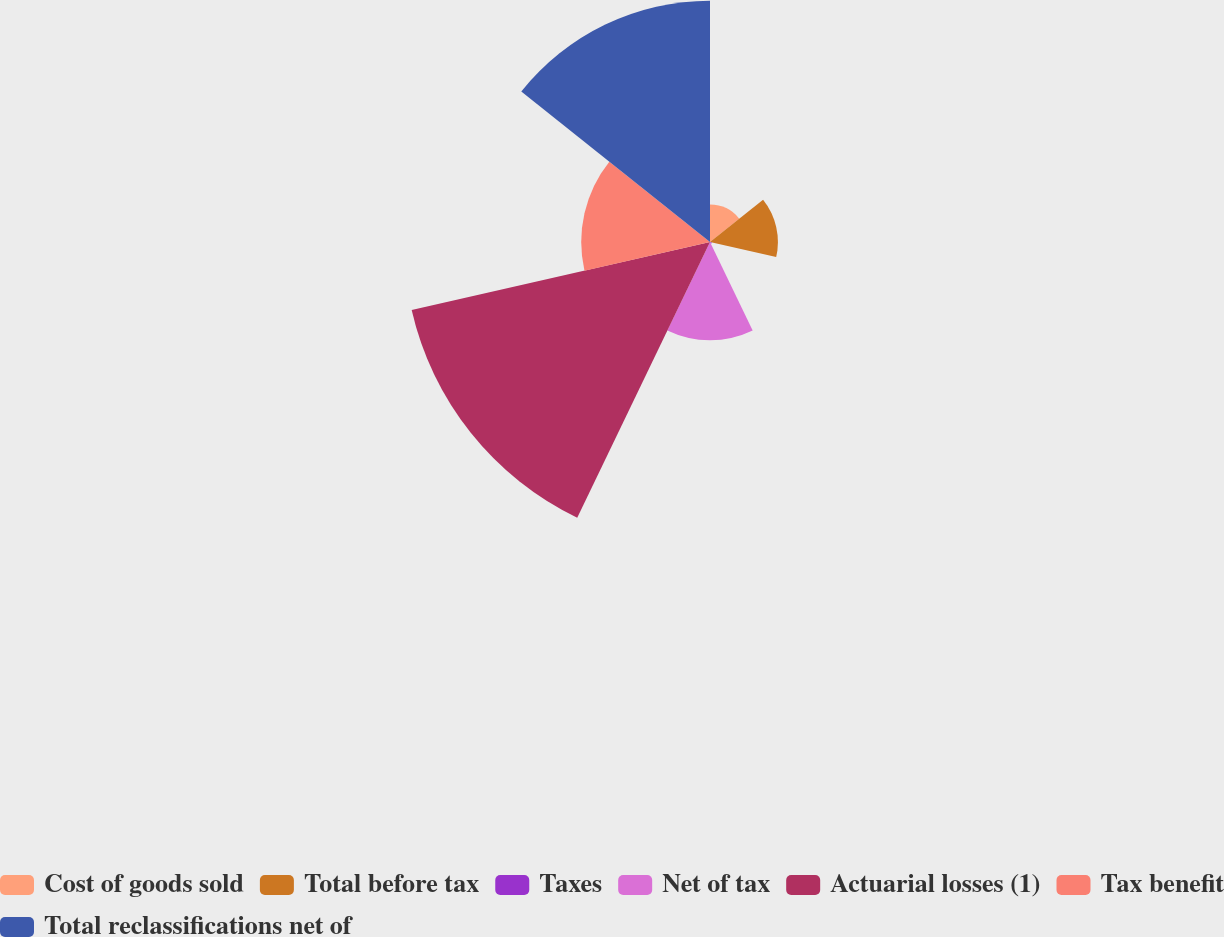Convert chart. <chart><loc_0><loc_0><loc_500><loc_500><pie_chart><fcel>Cost of goods sold<fcel>Total before tax<fcel>Taxes<fcel>Net of tax<fcel>Actuarial losses (1)<fcel>Tax benefit<fcel>Total reclassifications net of<nl><fcel>4.25%<fcel>7.7%<fcel>0.22%<fcel>11.15%<fcel>34.7%<fcel>14.6%<fcel>27.37%<nl></chart> 